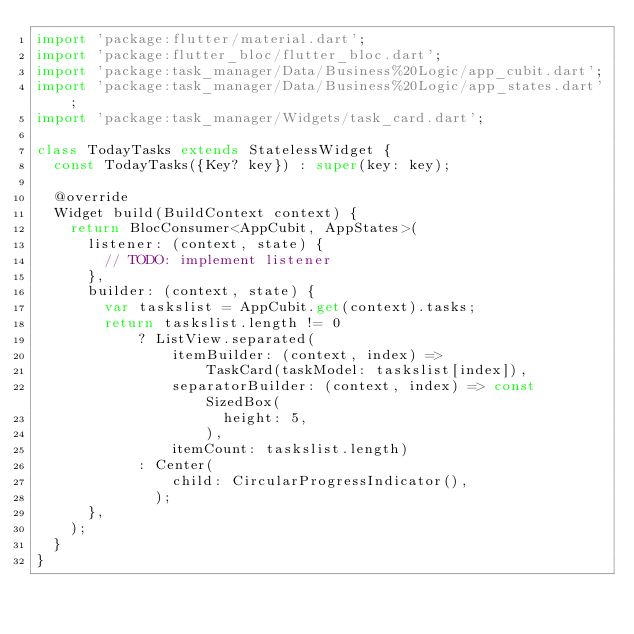Convert code to text. <code><loc_0><loc_0><loc_500><loc_500><_Dart_>import 'package:flutter/material.dart';
import 'package:flutter_bloc/flutter_bloc.dart';
import 'package:task_manager/Data/Business%20Logic/app_cubit.dart';
import 'package:task_manager/Data/Business%20Logic/app_states.dart';
import 'package:task_manager/Widgets/task_card.dart';

class TodayTasks extends StatelessWidget {
  const TodayTasks({Key? key}) : super(key: key);

  @override
  Widget build(BuildContext context) {
    return BlocConsumer<AppCubit, AppStates>(
      listener: (context, state) {
        // TODO: implement listener
      },
      builder: (context, state) {
        var taskslist = AppCubit.get(context).tasks;
        return taskslist.length != 0
            ? ListView.separated(
                itemBuilder: (context, index) =>
                    TaskCard(taskModel: taskslist[index]),
                separatorBuilder: (context, index) => const SizedBox(
                      height: 5,
                    ),
                itemCount: taskslist.length)
            : Center(
                child: CircularProgressIndicator(),
              );
      },
    );
  }
}
</code> 